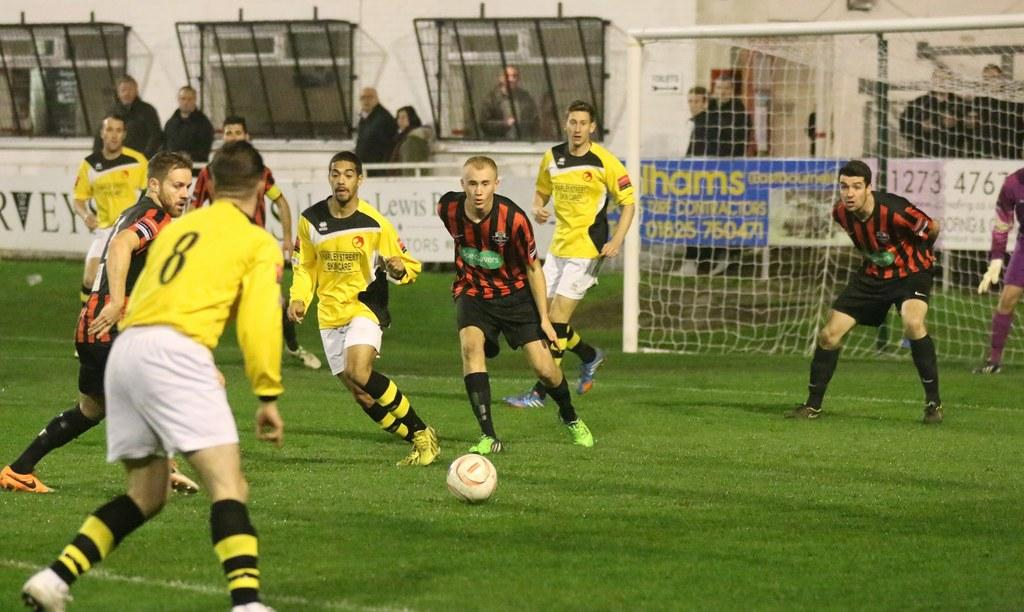<image>
Share a concise interpretation of the image provided. A group of men are playing soccer and one of them has the number 8 on his jersey. 